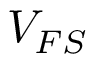<formula> <loc_0><loc_0><loc_500><loc_500>V _ { F S }</formula> 